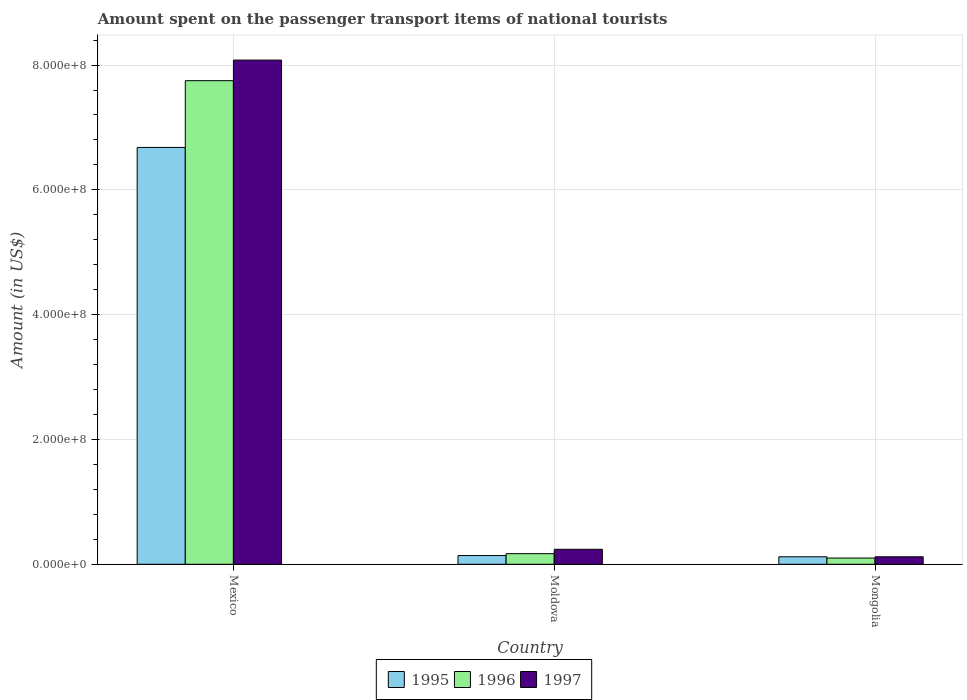Are the number of bars per tick equal to the number of legend labels?
Keep it short and to the point. Yes. How many bars are there on the 2nd tick from the right?
Your answer should be very brief. 3. What is the label of the 3rd group of bars from the left?
Your answer should be very brief. Mongolia. What is the amount spent on the passenger transport items of national tourists in 1995 in Mexico?
Your response must be concise. 6.68e+08. Across all countries, what is the maximum amount spent on the passenger transport items of national tourists in 1996?
Ensure brevity in your answer.  7.75e+08. In which country was the amount spent on the passenger transport items of national tourists in 1997 maximum?
Give a very brief answer. Mexico. In which country was the amount spent on the passenger transport items of national tourists in 1996 minimum?
Keep it short and to the point. Mongolia. What is the total amount spent on the passenger transport items of national tourists in 1997 in the graph?
Your response must be concise. 8.44e+08. What is the difference between the amount spent on the passenger transport items of national tourists in 1996 in Moldova and that in Mongolia?
Your answer should be very brief. 7.00e+06. What is the difference between the amount spent on the passenger transport items of national tourists in 1995 in Mongolia and the amount spent on the passenger transport items of national tourists in 1996 in Moldova?
Provide a succinct answer. -5.00e+06. What is the average amount spent on the passenger transport items of national tourists in 1995 per country?
Your response must be concise. 2.31e+08. What is the difference between the amount spent on the passenger transport items of national tourists of/in 1997 and amount spent on the passenger transport items of national tourists of/in 1995 in Mongolia?
Provide a succinct answer. 0. In how many countries, is the amount spent on the passenger transport items of national tourists in 1995 greater than 760000000 US$?
Offer a very short reply. 0. What is the ratio of the amount spent on the passenger transport items of national tourists in 1995 in Mexico to that in Moldova?
Keep it short and to the point. 47.71. Is the amount spent on the passenger transport items of national tourists in 1996 in Mexico less than that in Mongolia?
Provide a succinct answer. No. Is the difference between the amount spent on the passenger transport items of national tourists in 1997 in Mexico and Mongolia greater than the difference between the amount spent on the passenger transport items of national tourists in 1995 in Mexico and Mongolia?
Offer a terse response. Yes. What is the difference between the highest and the second highest amount spent on the passenger transport items of national tourists in 1995?
Provide a short and direct response. 6.56e+08. What is the difference between the highest and the lowest amount spent on the passenger transport items of national tourists in 1995?
Give a very brief answer. 6.56e+08. In how many countries, is the amount spent on the passenger transport items of national tourists in 1997 greater than the average amount spent on the passenger transport items of national tourists in 1997 taken over all countries?
Give a very brief answer. 1. Is the sum of the amount spent on the passenger transport items of national tourists in 1997 in Mexico and Moldova greater than the maximum amount spent on the passenger transport items of national tourists in 1995 across all countries?
Ensure brevity in your answer.  Yes. What does the 1st bar from the right in Mongolia represents?
Offer a terse response. 1997. How many bars are there?
Ensure brevity in your answer.  9. Are all the bars in the graph horizontal?
Provide a succinct answer. No. What is the difference between two consecutive major ticks on the Y-axis?
Ensure brevity in your answer.  2.00e+08. Does the graph contain any zero values?
Ensure brevity in your answer.  No. Does the graph contain grids?
Your answer should be compact. Yes. What is the title of the graph?
Your answer should be very brief. Amount spent on the passenger transport items of national tourists. Does "1990" appear as one of the legend labels in the graph?
Offer a terse response. No. What is the label or title of the X-axis?
Your response must be concise. Country. What is the label or title of the Y-axis?
Your response must be concise. Amount (in US$). What is the Amount (in US$) in 1995 in Mexico?
Give a very brief answer. 6.68e+08. What is the Amount (in US$) of 1996 in Mexico?
Ensure brevity in your answer.  7.75e+08. What is the Amount (in US$) in 1997 in Mexico?
Your response must be concise. 8.08e+08. What is the Amount (in US$) in 1995 in Moldova?
Your answer should be compact. 1.40e+07. What is the Amount (in US$) of 1996 in Moldova?
Ensure brevity in your answer.  1.70e+07. What is the Amount (in US$) of 1997 in Moldova?
Provide a short and direct response. 2.40e+07. What is the Amount (in US$) of 1997 in Mongolia?
Provide a succinct answer. 1.20e+07. Across all countries, what is the maximum Amount (in US$) in 1995?
Your answer should be compact. 6.68e+08. Across all countries, what is the maximum Amount (in US$) in 1996?
Offer a terse response. 7.75e+08. Across all countries, what is the maximum Amount (in US$) of 1997?
Offer a terse response. 8.08e+08. Across all countries, what is the minimum Amount (in US$) in 1997?
Your answer should be compact. 1.20e+07. What is the total Amount (in US$) of 1995 in the graph?
Ensure brevity in your answer.  6.94e+08. What is the total Amount (in US$) in 1996 in the graph?
Your response must be concise. 8.02e+08. What is the total Amount (in US$) of 1997 in the graph?
Offer a terse response. 8.44e+08. What is the difference between the Amount (in US$) in 1995 in Mexico and that in Moldova?
Make the answer very short. 6.54e+08. What is the difference between the Amount (in US$) in 1996 in Mexico and that in Moldova?
Make the answer very short. 7.58e+08. What is the difference between the Amount (in US$) in 1997 in Mexico and that in Moldova?
Keep it short and to the point. 7.84e+08. What is the difference between the Amount (in US$) of 1995 in Mexico and that in Mongolia?
Keep it short and to the point. 6.56e+08. What is the difference between the Amount (in US$) of 1996 in Mexico and that in Mongolia?
Your answer should be compact. 7.65e+08. What is the difference between the Amount (in US$) of 1997 in Mexico and that in Mongolia?
Your answer should be compact. 7.96e+08. What is the difference between the Amount (in US$) in 1995 in Moldova and that in Mongolia?
Your answer should be compact. 2.00e+06. What is the difference between the Amount (in US$) of 1995 in Mexico and the Amount (in US$) of 1996 in Moldova?
Provide a succinct answer. 6.51e+08. What is the difference between the Amount (in US$) of 1995 in Mexico and the Amount (in US$) of 1997 in Moldova?
Your response must be concise. 6.44e+08. What is the difference between the Amount (in US$) of 1996 in Mexico and the Amount (in US$) of 1997 in Moldova?
Keep it short and to the point. 7.51e+08. What is the difference between the Amount (in US$) in 1995 in Mexico and the Amount (in US$) in 1996 in Mongolia?
Ensure brevity in your answer.  6.58e+08. What is the difference between the Amount (in US$) of 1995 in Mexico and the Amount (in US$) of 1997 in Mongolia?
Ensure brevity in your answer.  6.56e+08. What is the difference between the Amount (in US$) of 1996 in Mexico and the Amount (in US$) of 1997 in Mongolia?
Ensure brevity in your answer.  7.63e+08. What is the difference between the Amount (in US$) of 1995 in Moldova and the Amount (in US$) of 1997 in Mongolia?
Your answer should be very brief. 2.00e+06. What is the average Amount (in US$) of 1995 per country?
Ensure brevity in your answer.  2.31e+08. What is the average Amount (in US$) of 1996 per country?
Ensure brevity in your answer.  2.67e+08. What is the average Amount (in US$) in 1997 per country?
Keep it short and to the point. 2.81e+08. What is the difference between the Amount (in US$) of 1995 and Amount (in US$) of 1996 in Mexico?
Give a very brief answer. -1.07e+08. What is the difference between the Amount (in US$) in 1995 and Amount (in US$) in 1997 in Mexico?
Keep it short and to the point. -1.40e+08. What is the difference between the Amount (in US$) of 1996 and Amount (in US$) of 1997 in Mexico?
Your answer should be compact. -3.30e+07. What is the difference between the Amount (in US$) in 1995 and Amount (in US$) in 1997 in Moldova?
Your response must be concise. -1.00e+07. What is the difference between the Amount (in US$) of 1996 and Amount (in US$) of 1997 in Moldova?
Provide a short and direct response. -7.00e+06. What is the ratio of the Amount (in US$) of 1995 in Mexico to that in Moldova?
Offer a very short reply. 47.71. What is the ratio of the Amount (in US$) in 1996 in Mexico to that in Moldova?
Offer a terse response. 45.59. What is the ratio of the Amount (in US$) of 1997 in Mexico to that in Moldova?
Your answer should be very brief. 33.67. What is the ratio of the Amount (in US$) in 1995 in Mexico to that in Mongolia?
Offer a very short reply. 55.67. What is the ratio of the Amount (in US$) of 1996 in Mexico to that in Mongolia?
Your response must be concise. 77.5. What is the ratio of the Amount (in US$) of 1997 in Mexico to that in Mongolia?
Your response must be concise. 67.33. What is the ratio of the Amount (in US$) in 1995 in Moldova to that in Mongolia?
Offer a very short reply. 1.17. What is the ratio of the Amount (in US$) in 1996 in Moldova to that in Mongolia?
Your answer should be compact. 1.7. What is the difference between the highest and the second highest Amount (in US$) of 1995?
Your answer should be very brief. 6.54e+08. What is the difference between the highest and the second highest Amount (in US$) of 1996?
Give a very brief answer. 7.58e+08. What is the difference between the highest and the second highest Amount (in US$) of 1997?
Your answer should be compact. 7.84e+08. What is the difference between the highest and the lowest Amount (in US$) of 1995?
Offer a very short reply. 6.56e+08. What is the difference between the highest and the lowest Amount (in US$) of 1996?
Your answer should be very brief. 7.65e+08. What is the difference between the highest and the lowest Amount (in US$) in 1997?
Give a very brief answer. 7.96e+08. 